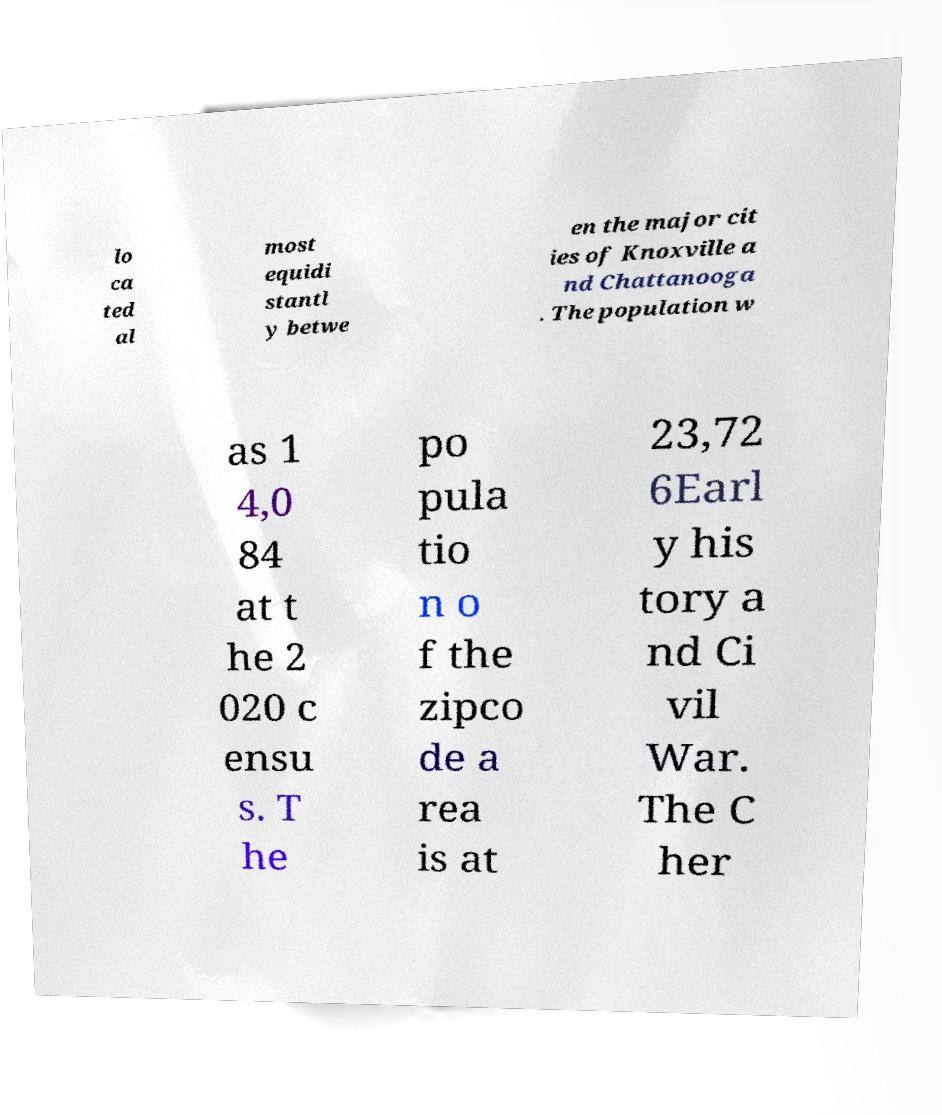Could you assist in decoding the text presented in this image and type it out clearly? lo ca ted al most equidi stantl y betwe en the major cit ies of Knoxville a nd Chattanooga . The population w as 1 4,0 84 at t he 2 020 c ensu s. T he po pula tio n o f the zipco de a rea is at 23,72 6Earl y his tory a nd Ci vil War. The C her 